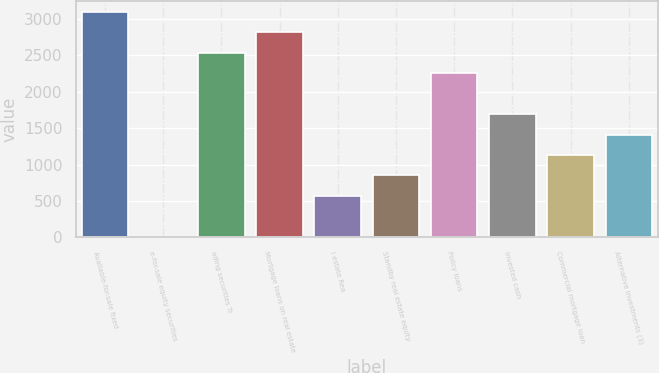Convert chart to OTSL. <chart><loc_0><loc_0><loc_500><loc_500><bar_chart><fcel>Available-for-sale fixed<fcel>e-for-sale equity securities<fcel>ading securities Tr<fcel>Mortgage loans on real estate<fcel>l estate Rea<fcel>Standby real estate equity<fcel>Policy loans<fcel>Invested cash<fcel>Commercial mortgage loan<fcel>Alternative investments (3)<nl><fcel>3094.5<fcel>9<fcel>2533.5<fcel>2814<fcel>570<fcel>850.5<fcel>2253<fcel>1692<fcel>1131<fcel>1411.5<nl></chart> 